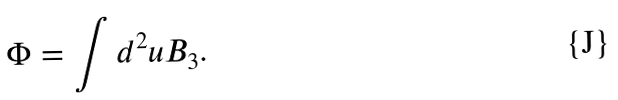Convert formula to latex. <formula><loc_0><loc_0><loc_500><loc_500>\Phi = \int d ^ { 2 } u B _ { 3 } .</formula> 